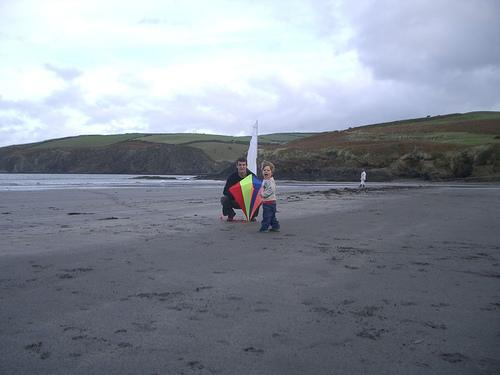What will this child hold while they play with this toy? Please explain your reasoning. string. The child will hold the string for the kite. 